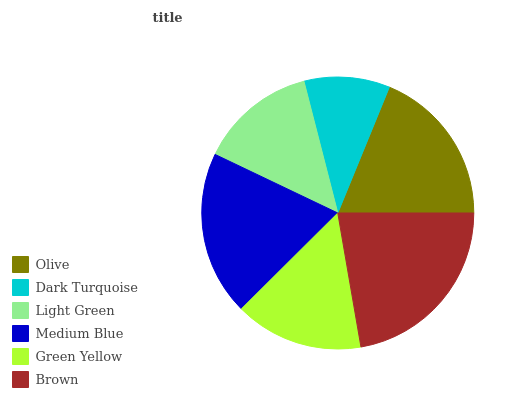Is Dark Turquoise the minimum?
Answer yes or no. Yes. Is Brown the maximum?
Answer yes or no. Yes. Is Light Green the minimum?
Answer yes or no. No. Is Light Green the maximum?
Answer yes or no. No. Is Light Green greater than Dark Turquoise?
Answer yes or no. Yes. Is Dark Turquoise less than Light Green?
Answer yes or no. Yes. Is Dark Turquoise greater than Light Green?
Answer yes or no. No. Is Light Green less than Dark Turquoise?
Answer yes or no. No. Is Olive the high median?
Answer yes or no. Yes. Is Green Yellow the low median?
Answer yes or no. Yes. Is Medium Blue the high median?
Answer yes or no. No. Is Brown the low median?
Answer yes or no. No. 